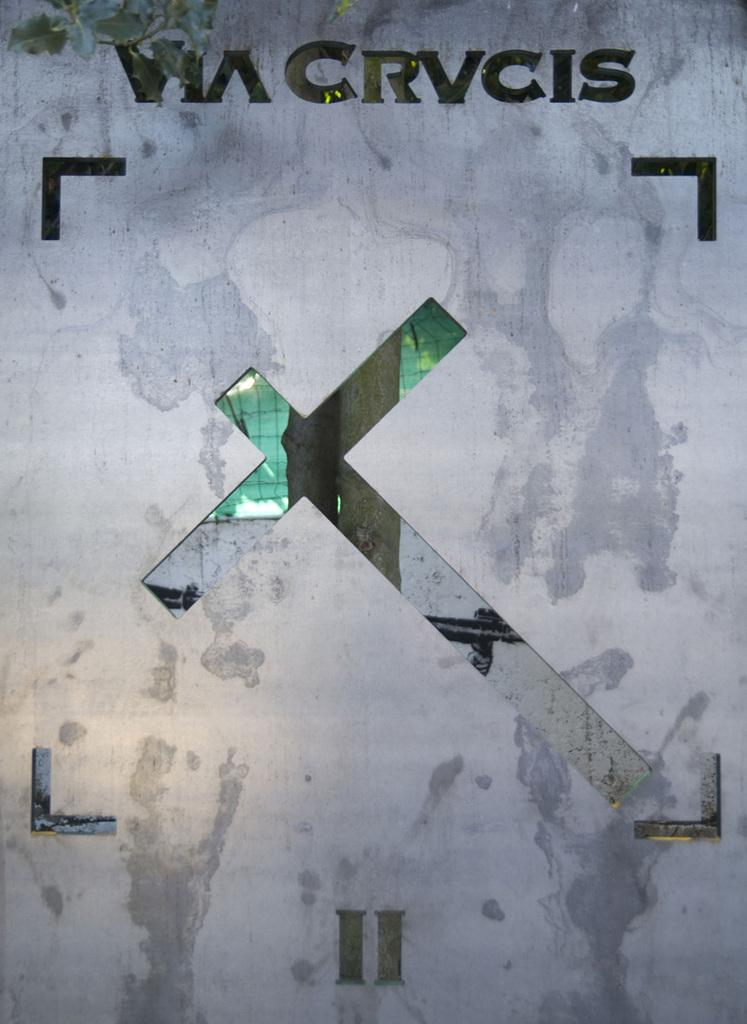How has the image been altered or modified? The image is edited. What religious symbol can be seen in the image? There is a holy cross symbol in the image. Are there any words or letters in the image? Yes, there are letters in the image. What is visible through the holy cross symbol? A tree trunk is visible through the holy cross symbol. What type of structure is present in the image? There is a wall in the image. What type of barrier is present in the image? A fence is present in the image. What role does the partner play in the image? There is no partner present in the image, so it is not possible to determine their role. How does the mother interact with the holy cross symbol in the image? There is no mother present in the image, so it is not possible to determine their interaction with the holy cross symbol. 